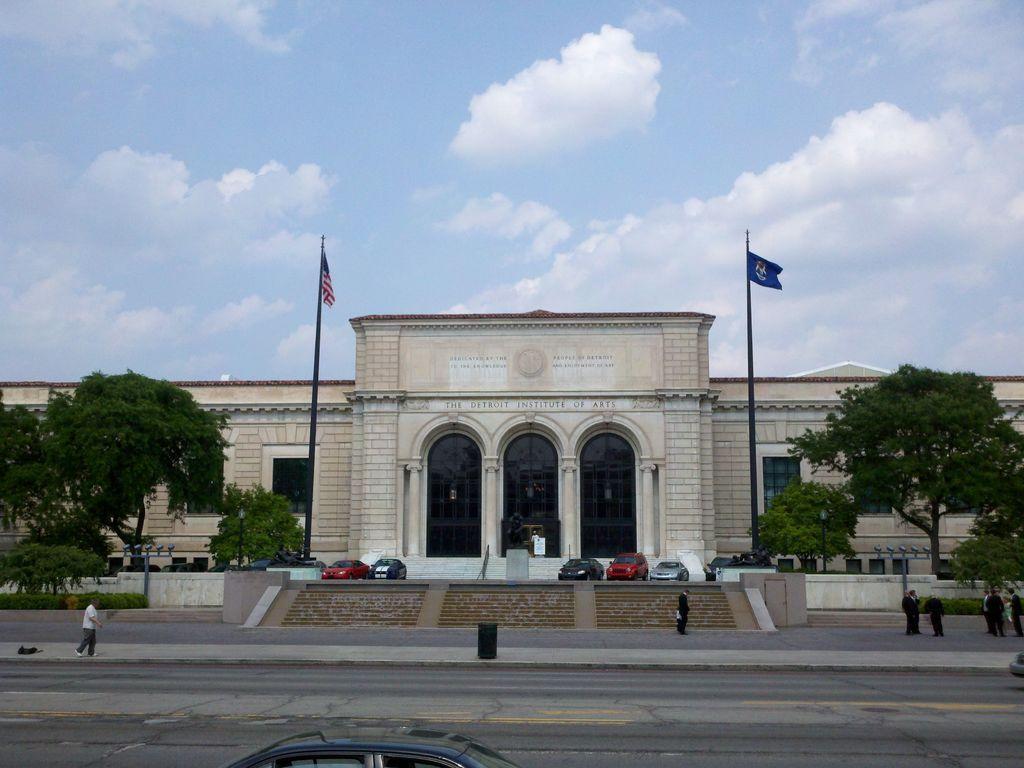Could you give a brief overview of what you see in this image? In the picture I can see people walking on the road, I can see a car here, I can see a few more cars parked there, I can see flags to the poles, trees, stone building and the blue color sky with clouds in the background. 